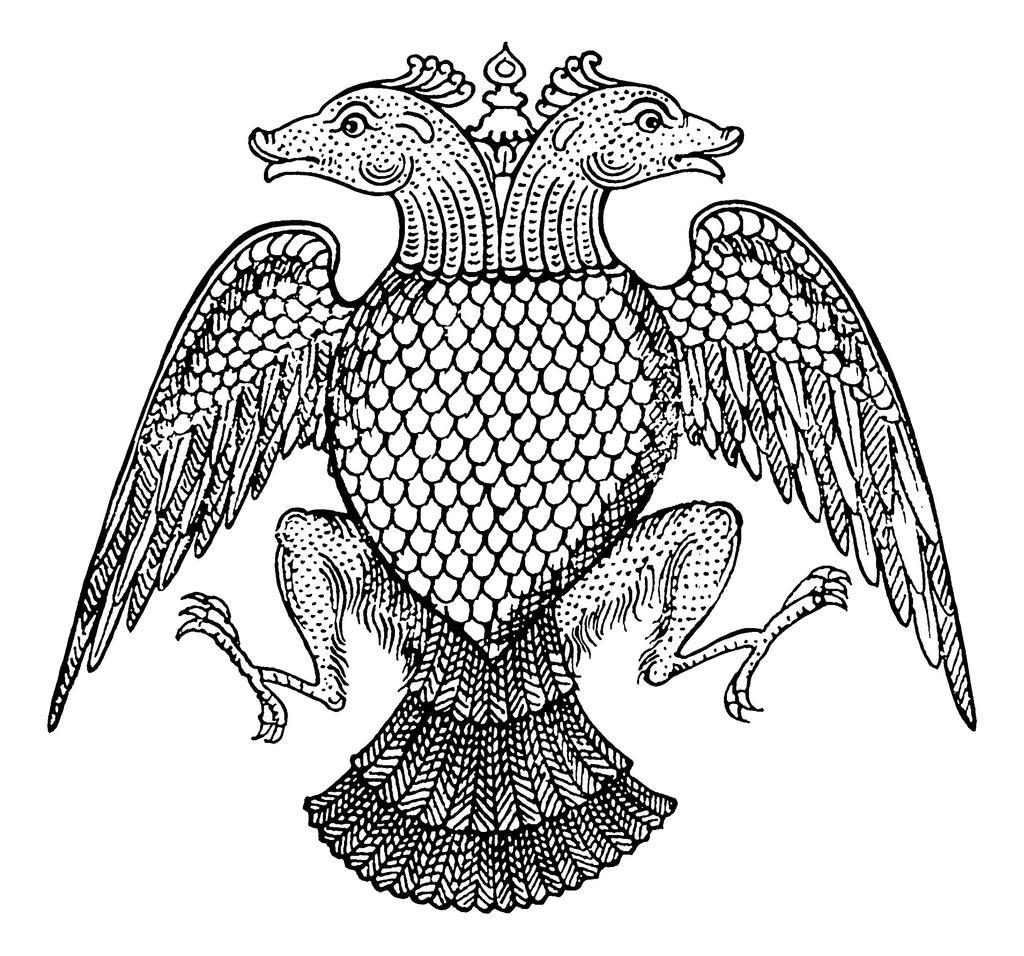What is the main subject of the image? There is a picture in the image. How many chickens are visible in the picture? There is no chicken present in the image, as the main subject is a picture. What message of peace can be seen in the picture? There is no message of peace present in the image, as the main subject is a picture. 